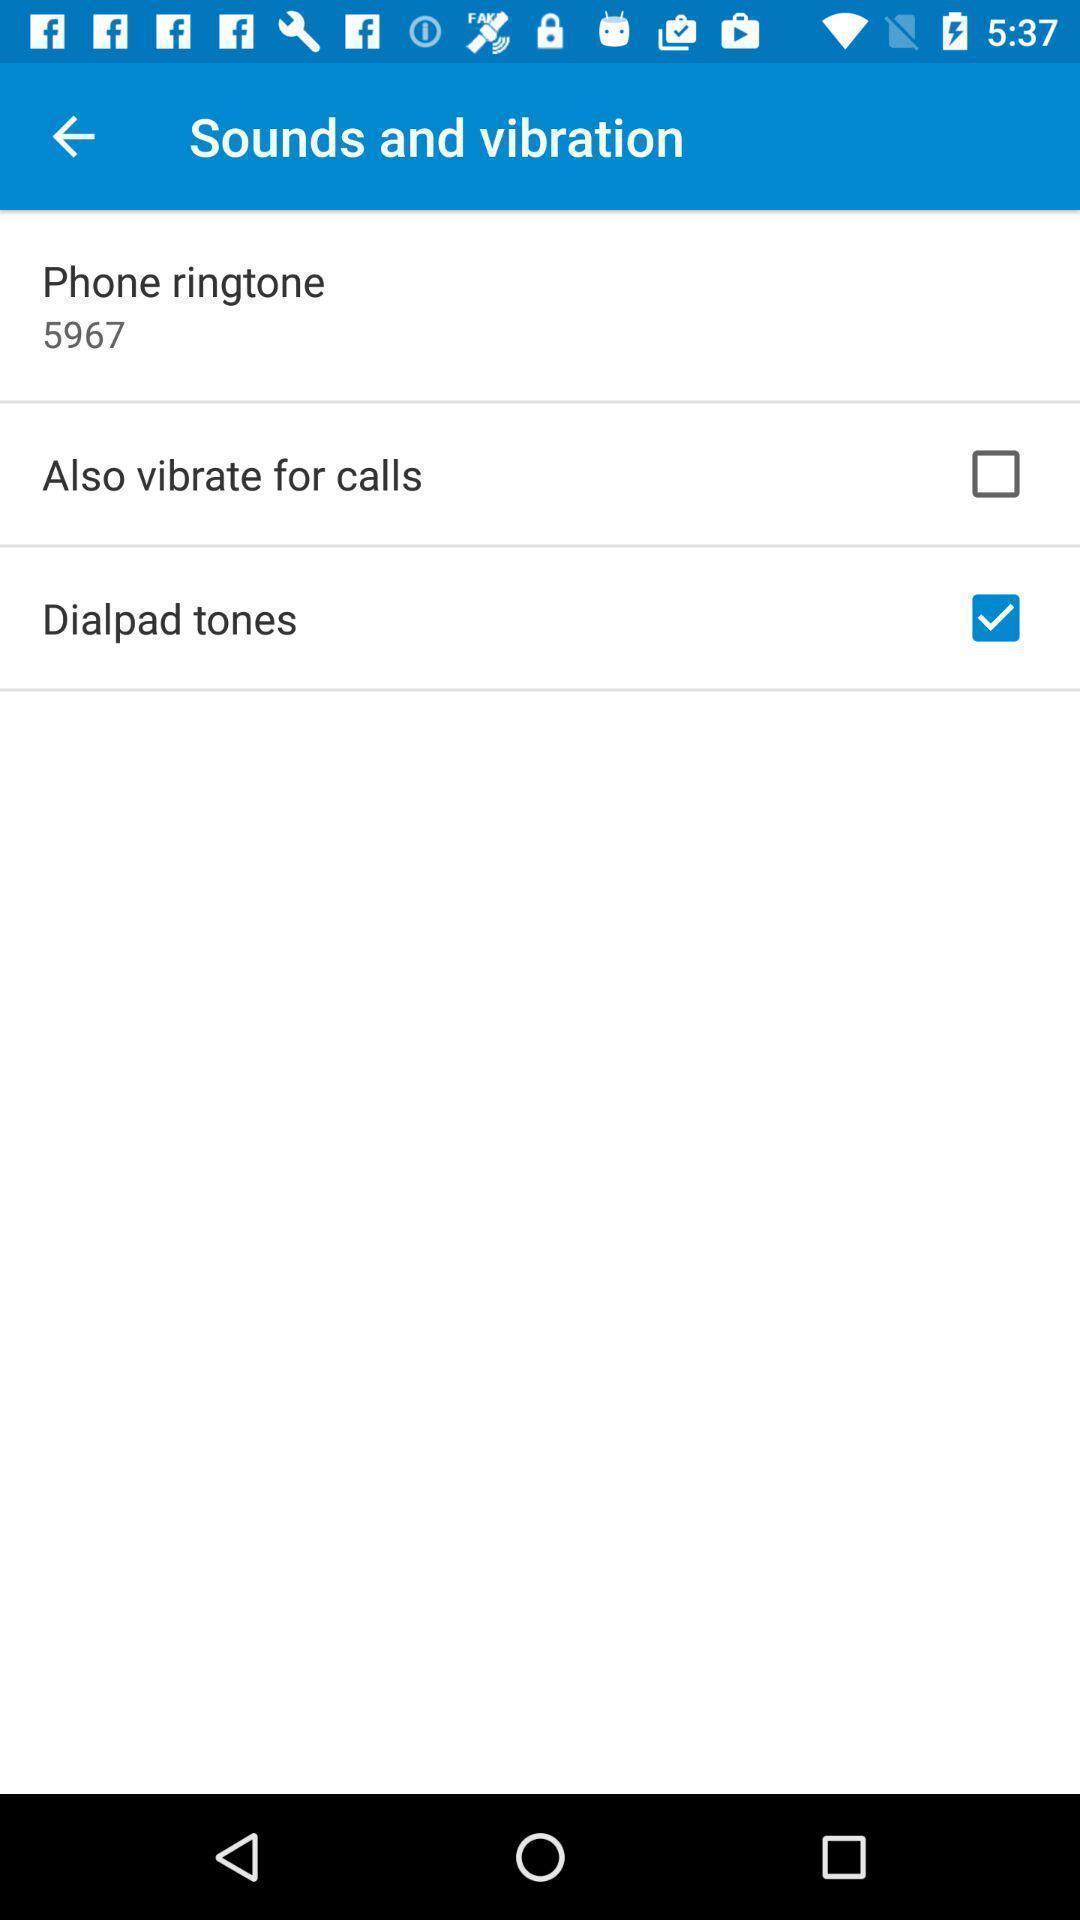Explain what's happening in this screen capture. Sounds and vibration settings page. 